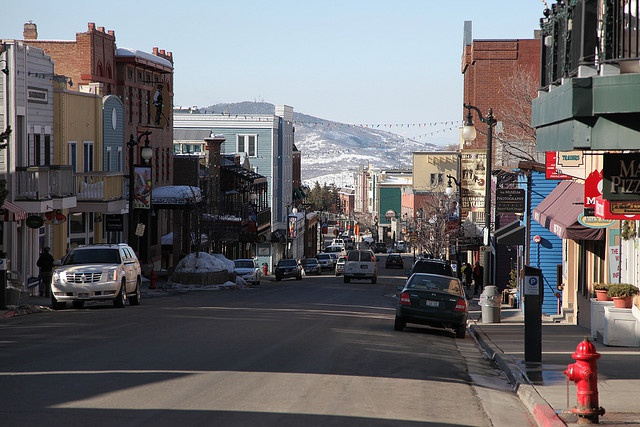Describe the objects in this image and their specific colors. I can see car in lightblue, black, gray, darkgray, and lightgray tones, car in lightblue, black, gray, and maroon tones, fire hydrant in lightblue, maroon, black, salmon, and red tones, parking meter in lightblue, black, gray, navy, and darkblue tones, and car in lightblue, black, gray, and darkblue tones in this image. 